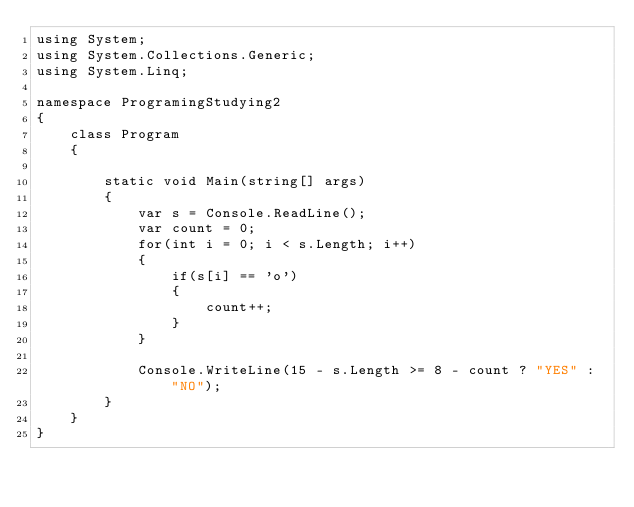<code> <loc_0><loc_0><loc_500><loc_500><_C#_>using System;
using System.Collections.Generic;
using System.Linq;

namespace ProgramingStudying2
{
    class Program
    {

        static void Main(string[] args)
        {
            var s = Console.ReadLine();
            var count = 0;
            for(int i = 0; i < s.Length; i++)
            {
                if(s[i] == 'o')
                {
                    count++;
                }
            }

            Console.WriteLine(15 - s.Length >= 8 - count ? "YES" : "NO");
        }
    }
}
</code> 